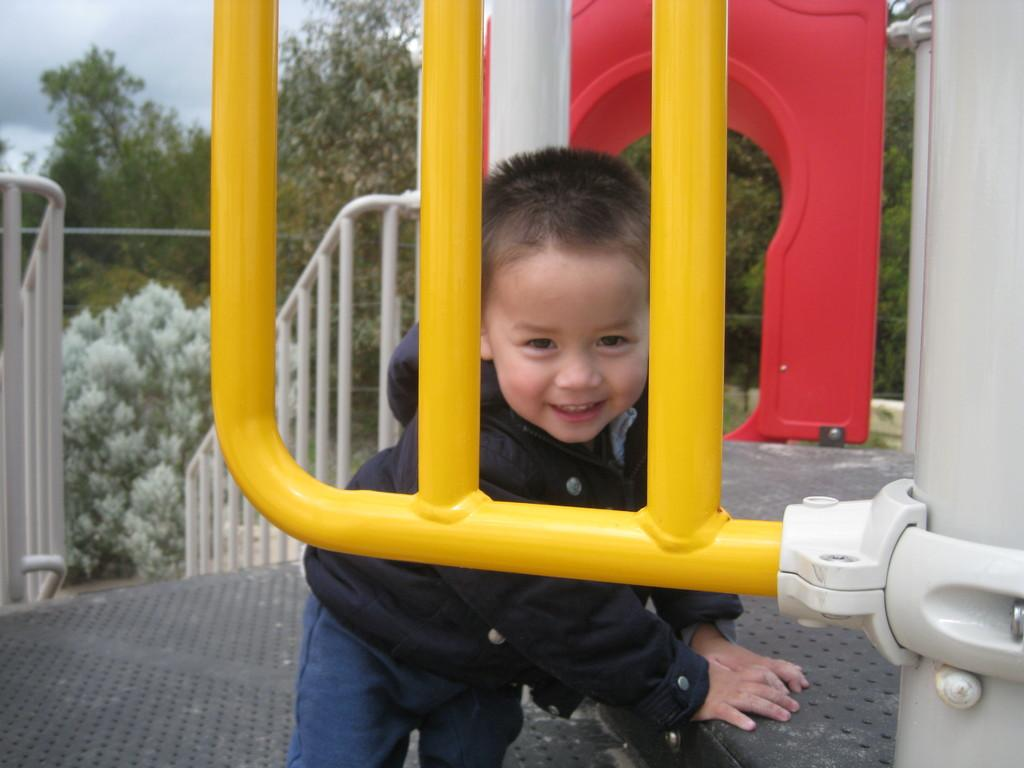What is the main subject of the image? There is a kid in the image. What can be seen near the kid? There are handrails in the image. What color is one of the objects in the image? There is a red-colored object in the image. What type of natural scenery is visible in the image? There are trees in the image. What is visible in the background of the image? The sky is visible in the image. What level of debt is the kid facing in the image? There is no indication of debt in the image, as it features a kid and various objects and elements. 